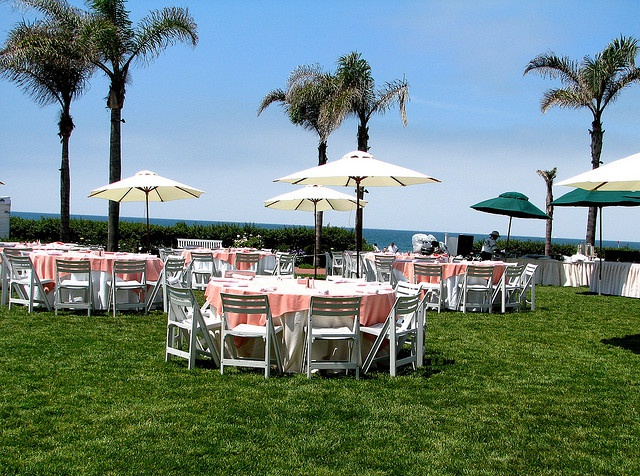Describe the objects in this image and their specific colors. I can see chair in gray, white, black, and darkgray tones, chair in gray, black, lightgray, and darkgreen tones, chair in gray, black, darkgreen, and darkgray tones, dining table in gray, white, brown, and lightpink tones, and umbrella in gray, white, beige, black, and darkgray tones in this image. 